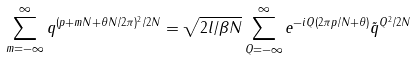Convert formula to latex. <formula><loc_0><loc_0><loc_500><loc_500>\sum _ { m = - \infty } ^ { \infty } q ^ { ( p + m N + \theta N / 2 \pi ) ^ { 2 } / 2 N } = \sqrt { 2 l / \beta N } \sum _ { Q = - \infty } ^ { \infty } e ^ { - i Q ( 2 \pi p / N + \theta ) } \tilde { q } ^ { Q ^ { 2 } / 2 N }</formula> 